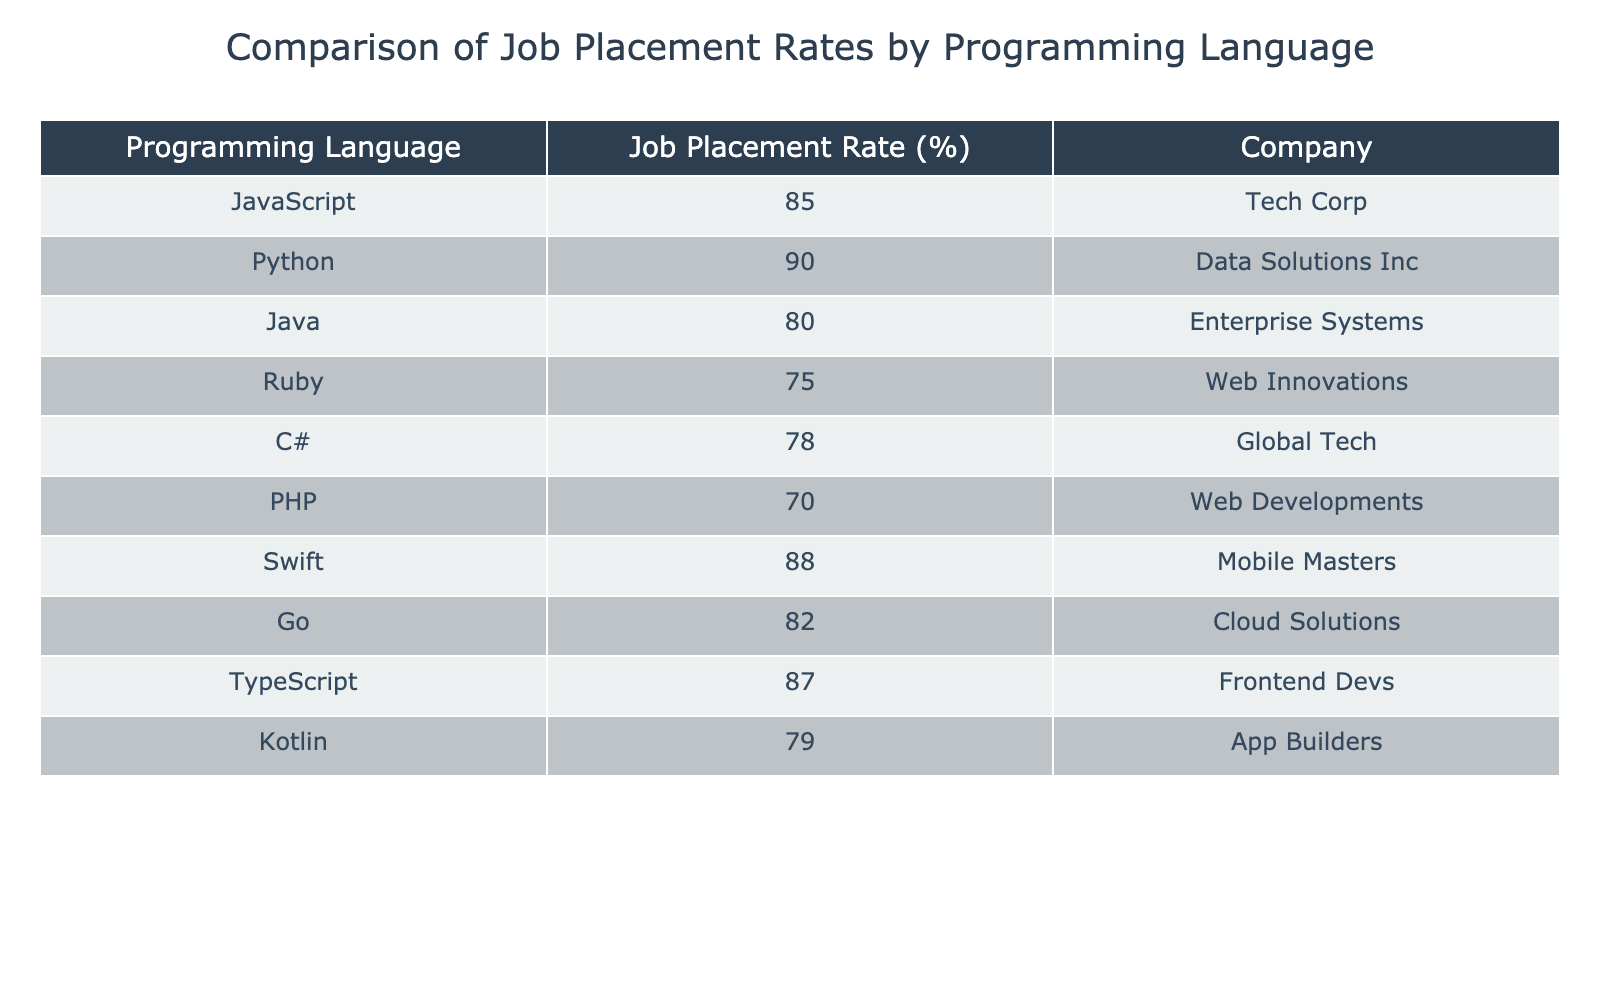What is the job placement rate for JavaScript? The table shows that the job placement rate for JavaScript is 85%. This can be directly retrieved from the corresponding row in the table where JavaScript is listed.
Answer: 85% Which programming language has the highest job placement rate? Looking through the job placement rates listed in the table, Python has the highest placement rate at 90%. This is the maximum value in the "Job Placement Rate (%)" column.
Answer: 90% What is the average job placement rate for the following languages: Java, Ruby, and C#? The job placement rates for Java, Ruby, and C# are 80%, 75%, and 78%, respectively. First, sum these rates: 80 + 75 + 78 = 233. Then, divide by the number of languages (3) to find the average: 233 / 3 ≈ 77.67.
Answer: 77.67 Is the job placement rate for Swift higher than that for PHP? The job placement rate for Swift is 88%, while for PHP it is 70%. Since 88% is greater than 70%, the statement is true. This can be confirmed by comparing the values directly from the table.
Answer: Yes How many programming languages have a job placement rate above 80%? The languages with rates above 80% are JavaScript (85%), Python (90%), Swift (88%), TypeScript (87%), and Go (82%). That totals 5 languages. By counting the number of entries that exceed 80% in the "Job Placement Rate (%)" column, we find there are five.
Answer: 5 Which programming language has a job placement rate closest to 80%? Upon reviewing the job placement rates, Java is at 80%, Kotlin is at 79%, and C# is at 78%. The row that corresponds to these languages indicates that Java is precisely 80%, while Kotlin and C# are slightly less. So, Java has the closest rate.
Answer: Java What is the difference in job placement rates between the highest and lowest placement rates? The highest placement rate is for Python at 90%, and the lowest is for PHP at 70%. The difference is calculated by subtracting the lowest from the highest: 90 - 70 = 20. This provides the final result regarding the variation between these two programming languages.
Answer: 20 Does any language have an exact job placement rate of 75%? Upon examining the table, Ruby has a job placement rate of exactly 75%. This is confirmed by locating the entry for Ruby in the table.
Answer: Yes What is the job placement rate for TypeScript, and how does it compare to that of Ruby? TypeScript has a job placement rate of 87%, while Ruby has a rate of 75%. To compare, we see that 87% is significantly higher than 75%. This indicates that TypeScript has a better placement rate.
Answer: 87% (TypeScript is higher than Ruby) 